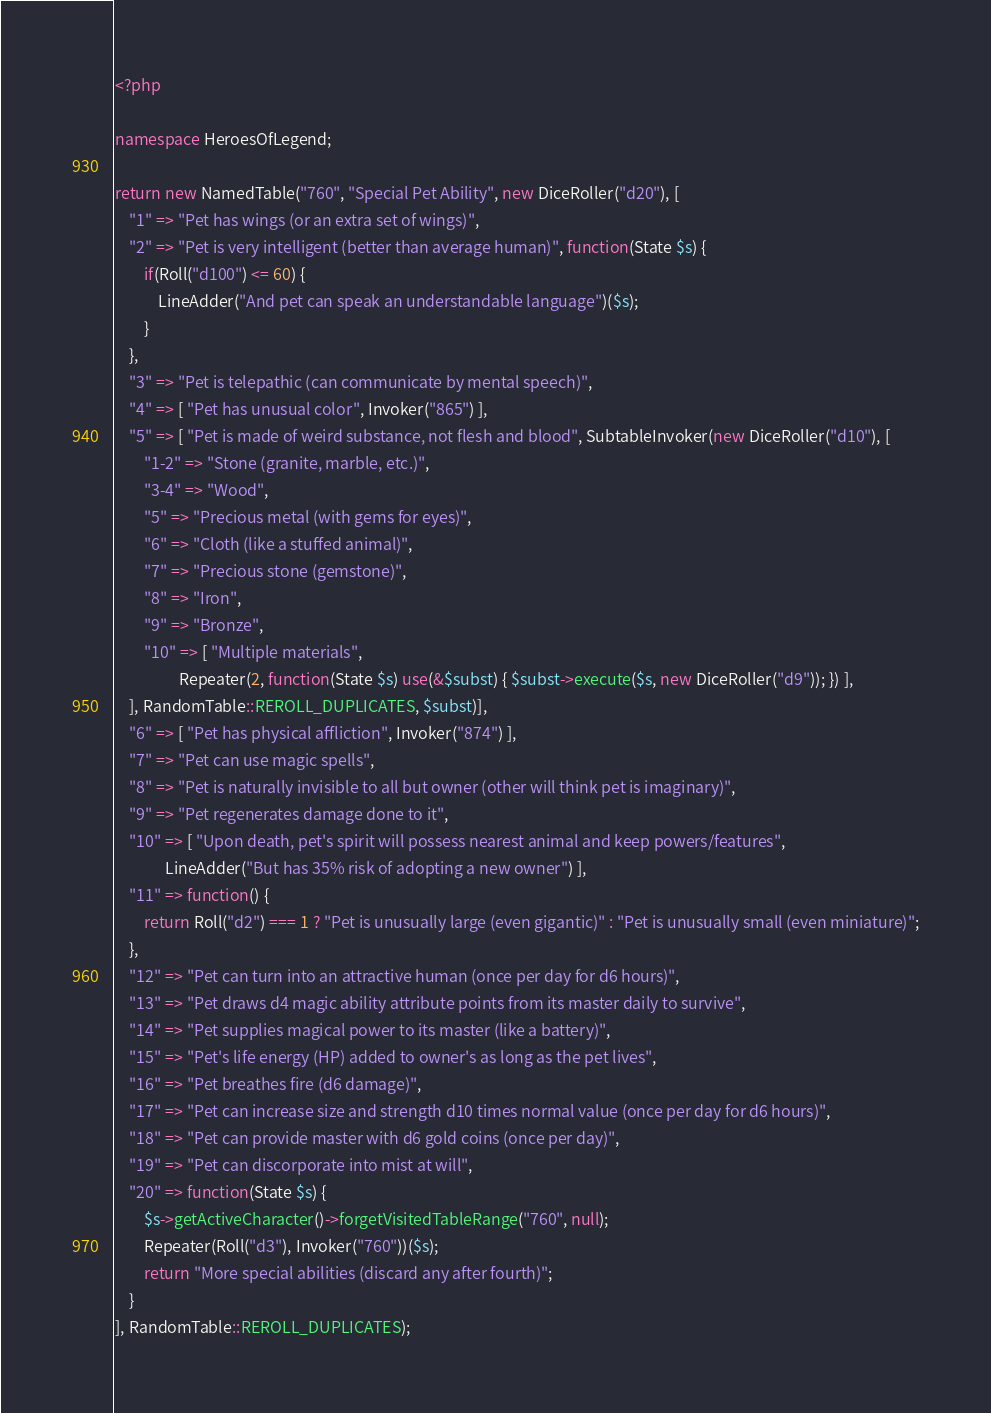Convert code to text. <code><loc_0><loc_0><loc_500><loc_500><_PHP_><?php

namespace HeroesOfLegend;

return new NamedTable("760", "Special Pet Ability", new DiceRoller("d20"), [
	"1" => "Pet has wings (or an extra set of wings)",
	"2" => "Pet is very intelligent (better than average human)", function(State $s) {
		if(Roll("d100") <= 60) {
			LineAdder("And pet can speak an understandable language")($s);
		}
	},
	"3" => "Pet is telepathic (can communicate by mental speech)",
	"4" => [ "Pet has unusual color", Invoker("865") ],
	"5" => [ "Pet is made of weird substance, not flesh and blood", SubtableInvoker(new DiceRoller("d10"), [
		"1-2" => "Stone (granite, marble, etc.)",
		"3-4" => "Wood",
		"5" => "Precious metal (with gems for eyes)",
		"6" => "Cloth (like a stuffed animal)",
		"7" => "Precious stone (gemstone)",
		"8" => "Iron",
		"9" => "Bronze",
		"10" => [ "Multiple materials",
		          Repeater(2, function(State $s) use(&$subst) { $subst->execute($s, new DiceRoller("d9")); }) ],
	], RandomTable::REROLL_DUPLICATES, $subst)],
	"6" => [ "Pet has physical affliction", Invoker("874") ],
	"7" => "Pet can use magic spells",
	"8" => "Pet is naturally invisible to all but owner (other will think pet is imaginary)",
	"9" => "Pet regenerates damage done to it",
	"10" => [ "Upon death, pet's spirit will possess nearest animal and keep powers/features",
	          LineAdder("But has 35% risk of adopting a new owner") ],
	"11" => function() {
		return Roll("d2") === 1 ? "Pet is unusually large (even gigantic)" : "Pet is unusually small (even miniature)";
	},
	"12" => "Pet can turn into an attractive human (once per day for d6 hours)",
	"13" => "Pet draws d4 magic ability attribute points from its master daily to survive",
	"14" => "Pet supplies magical power to its master (like a battery)",
	"15" => "Pet's life energy (HP) added to owner's as long as the pet lives",
	"16" => "Pet breathes fire (d6 damage)",
	"17" => "Pet can increase size and strength d10 times normal value (once per day for d6 hours)",
	"18" => "Pet can provide master with d6 gold coins (once per day)",
	"19" => "Pet can discorporate into mist at will",
	"20" => function(State $s) {
		$s->getActiveCharacter()->forgetVisitedTableRange("760", null);
		Repeater(Roll("d3"), Invoker("760"))($s);
		return "More special abilities (discard any after fourth)";
	}
], RandomTable::REROLL_DUPLICATES);
</code> 